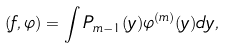<formula> <loc_0><loc_0><loc_500><loc_500>( f , \varphi ) = \int P _ { m - 1 } ( y ) \varphi ^ { ( m ) } ( y ) d y ,</formula> 